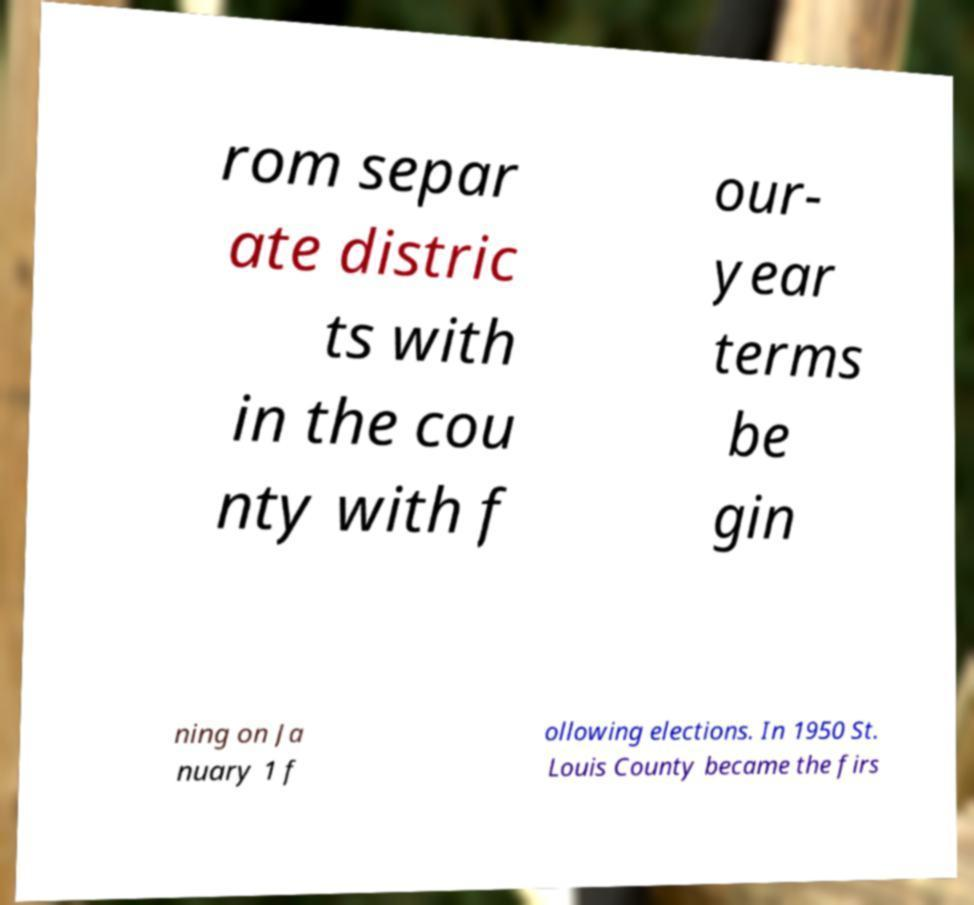Can you accurately transcribe the text from the provided image for me? rom separ ate distric ts with in the cou nty with f our- year terms be gin ning on Ja nuary 1 f ollowing elections. In 1950 St. Louis County became the firs 